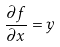<formula> <loc_0><loc_0><loc_500><loc_500>\frac { \partial f } { \partial x } = y</formula> 